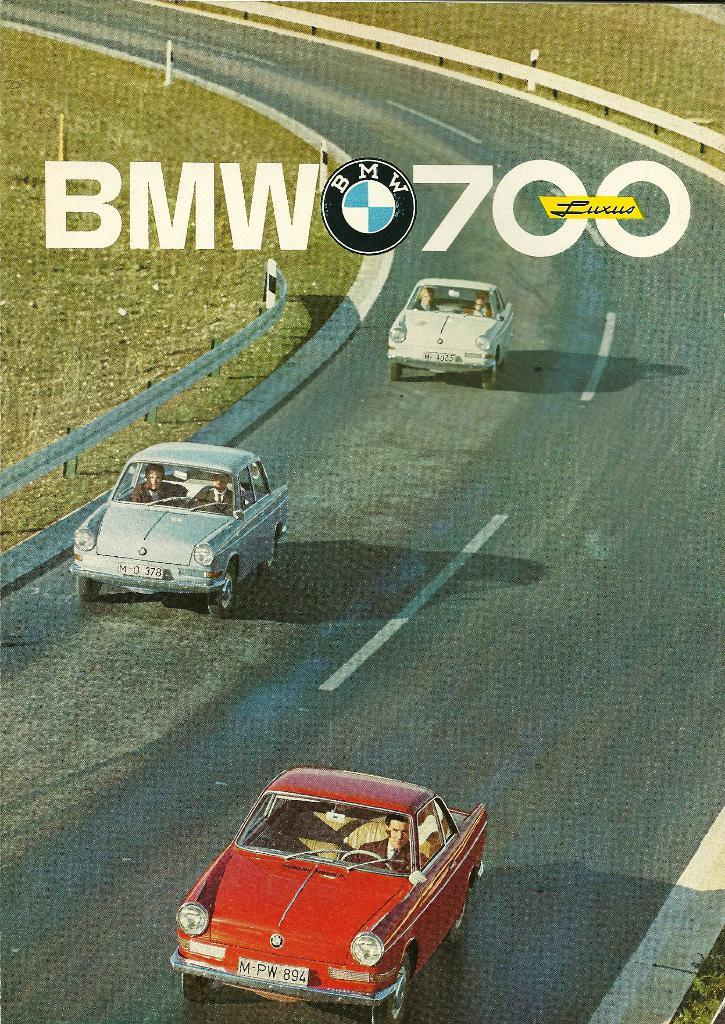How many cars can be seen on the road in the image? There are three cars on the road in the image. What else is visible in the image besides the cars? There is a text visible in the image, as well as a fence and grass. What is the weather like in the image? The image was taken during a sunny day. What type of tooth is being used to defuse the bomb in the image? There is no tooth or bomb present in the image. What invention is being showcased in the image? The image does not showcase any specific invention; it features three cars on the road, a text, a fence, grass, and a sunny day. 